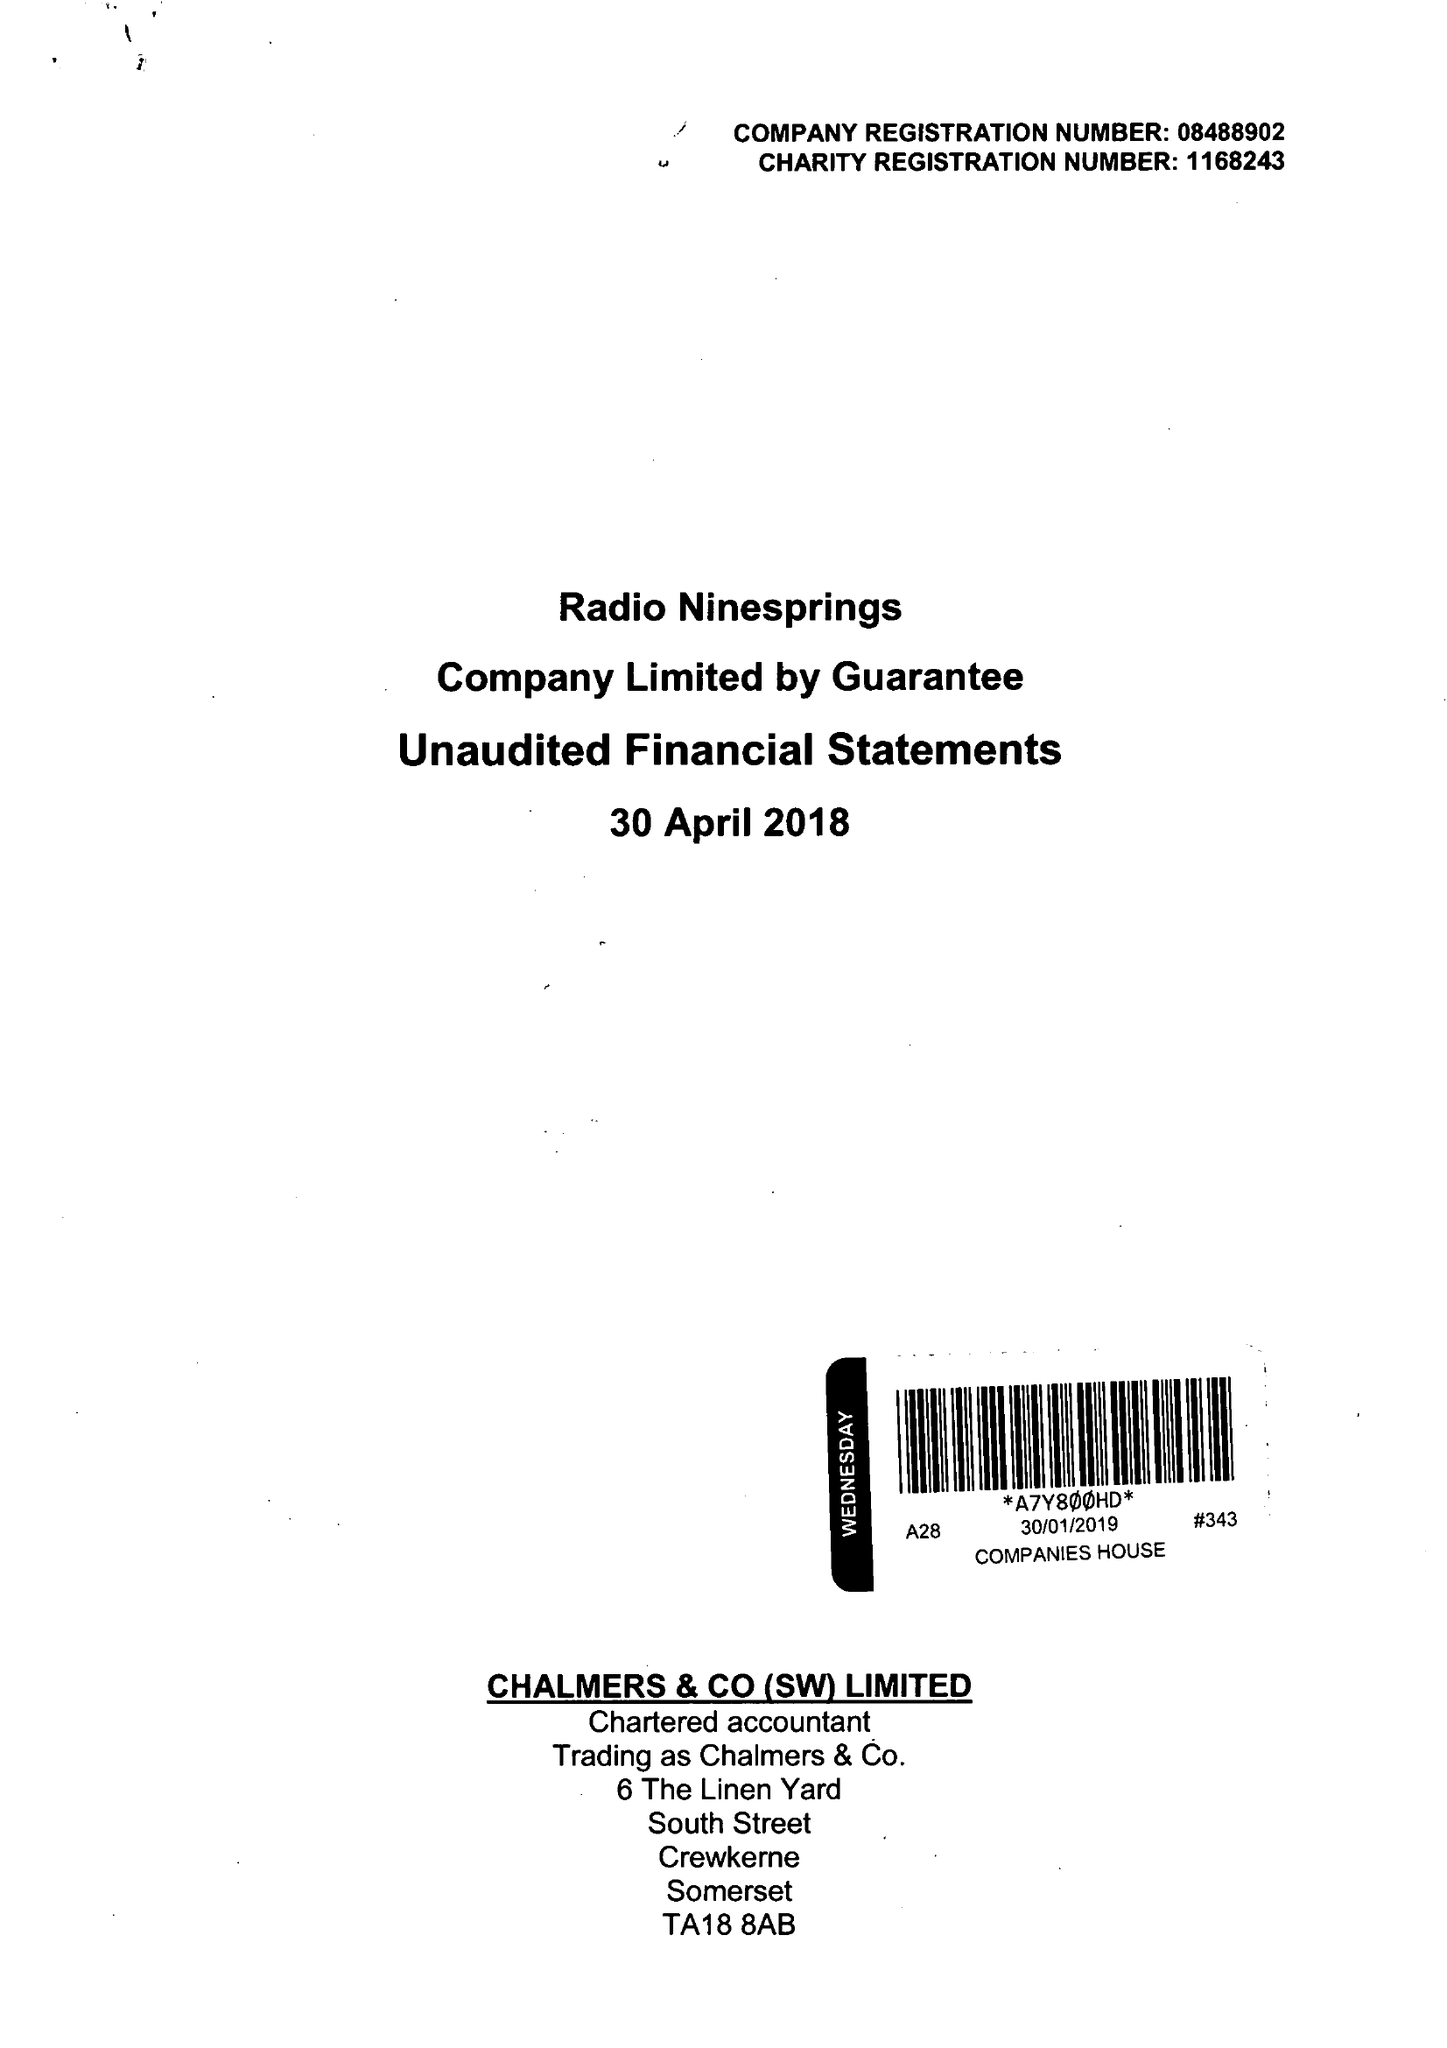What is the value for the spending_annually_in_british_pounds?
Answer the question using a single word or phrase. 29633.00 